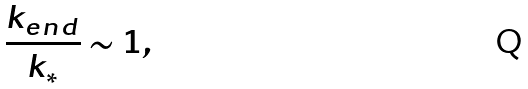Convert formula to latex. <formula><loc_0><loc_0><loc_500><loc_500>\frac { k _ { e n d } } { k _ { * } } \sim 1 ,</formula> 